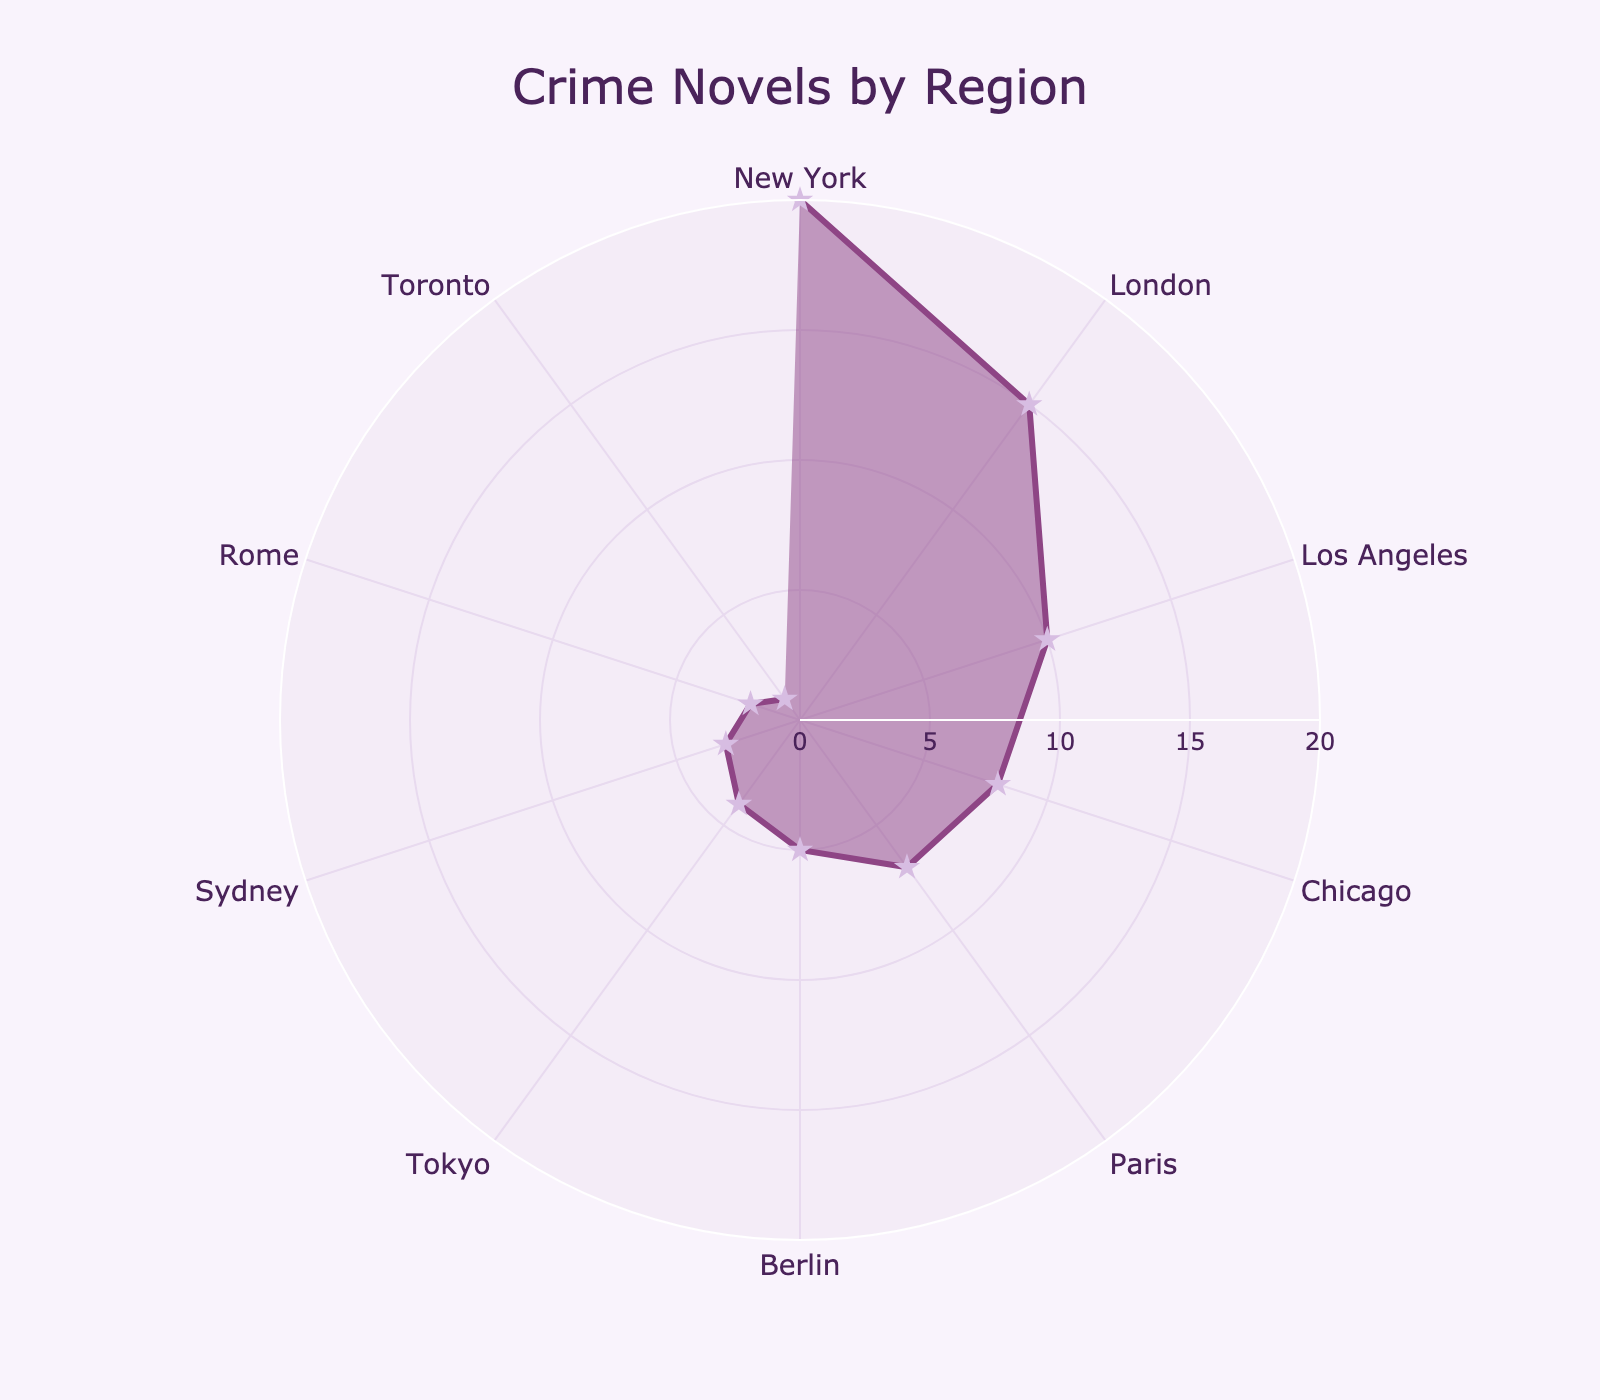Which region has the highest number of crime novels? The region with the highest number of crime novels will be the one with the tallest bar or largest value in the radar chart.
Answer: New York Which region has the lowest number of crime novels? The region with the lowest number of crime novels will be associated with the smallest value in the radar chart.
Answer: Toronto What is the title of the radar chart? The title is usually positioned at the top of the chart and describes the overall content.
Answer: Crime Novels by Region How many regions are represented in the radar chart? Counting the unique points/radial lines on the radar chart gives the total number of regions.
Answer: 10 What is the sum of crime novels set in London, Paris, and Tokyo? Add the number of novels in London (15), Paris (7), and Tokyo (4). Sum: 15 + 7 + 4 = 26.
Answer: 26 Which has more crime novels, Los Angeles or Chicago? Compare the values for Los Angeles (10) and Chicago (8) on the radar chart.
Answer: Los Angeles What is the difference in the number of crime novels between New York and Berlin? Subtract the number of novels in Berlin (5) from New York (20). Difference: 20 - 5 = 15.
Answer: 15 Is the number of crime novels set in Sydney greater than in Rome? Compare the values for Sydney (3) and Rome (2) on the radar chart.
Answer: Yes What are the colors used for the lines and markers in the radar chart? Identify the specific colors used for the lines and markers by observing the chart.
Answer: Lines: purple, Markers: light purple What is the average number of crime novels per region? Sum all the values and divide by the number of regions: (20+15+10+8+7+5+4+3+2+1)/10 = 75/10 = 7.5.
Answer: 7.5 